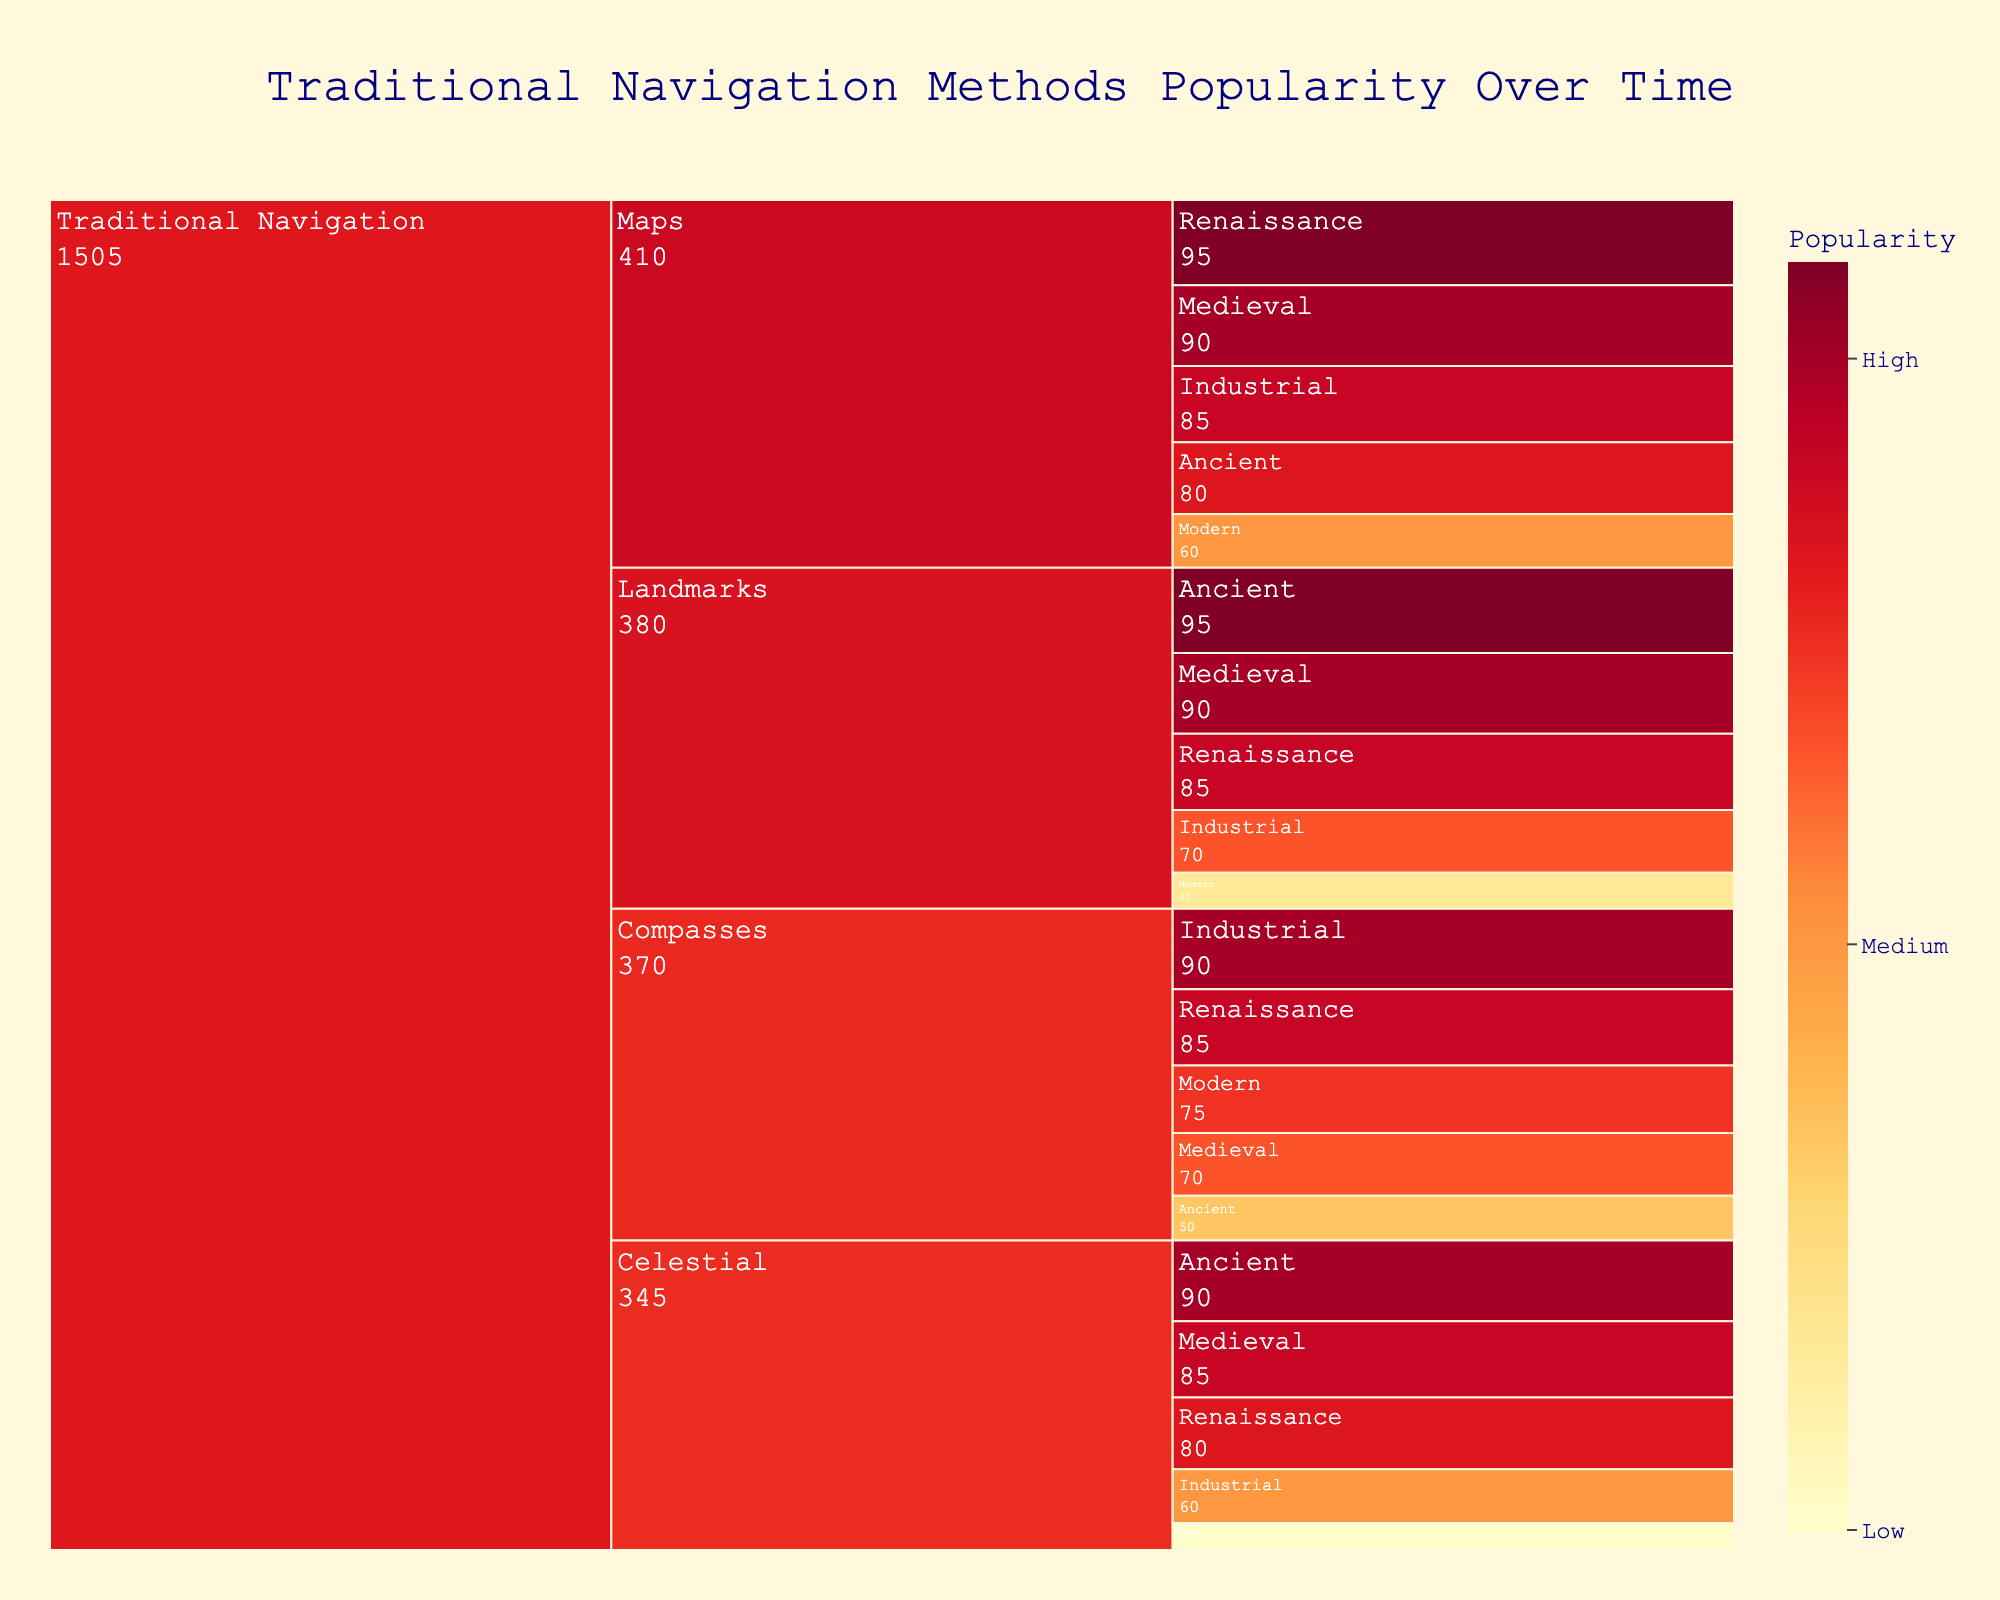What's the title of the figure? The title of the figure is written at the top of the chart.
Answer: Traditional Navigation Methods Popularity Over Time Which type of traditional navigation had the highest popularity in the Renaissance era? By looking at the Renaissance segment for each type and comparing their values, you'll see the highest number is under "Maps" with a value of 95.
Answer: Maps What is the least popular traditional navigation method in the modern era? Examine the modern era section for all types and identify the lowest value, which is "Celestial" with a value of 30.
Answer: Celestial How did the popularity of maps change from the ancient era to the modern era? The popularity for maps in the ancient era is 80 and in the modern era is 60. Subtract the modern value from the ancient value: 80 - 60 = 20, indicating a decrease of 20.
Answer: Decreased by 20 What is the average popularity of compasses over the five eras? Add the popularity values for compasses across all eras: 50 (Ancient) + 70 (Medieval) + 85 (Renaissance) + 90 (Industrial) + 75 (Modern) = 370, then divide by 5, which gives 370 / 5 = 74.
Answer: 74 Which traditional navigation method showed the most significant decline in popularity from the Industrial to the Modern era? For each method, find the difference in popularity between the Industrial and Modern eras: Maps (85 - 60 = 25), Compasses (90 - 75 = 15), Celestial (60 - 30 = 30), Landmarks (70 - 40 = 30). Both Celestial and Landmarks showed a decline of 30.
Answer: Celestial and Landmarks What is the total popularity of traditional navigation methods in the Medieval era? Sum the popularity values of all methods in the Medieval era: Maps (90) + Compasses (70) + Celestial (85) + Landmarks (90), which totals to 90 + 70 + 85 + 90 = 335.
Answer: 335 Which navigation method had a consistent decline in popularity across all eras? By looking at each era's values for all navigation methods, only "Celestial" shows a consistent decline: Ancient (90) > Medieval (85) > Renaissance (80) > Industrial (60) > Modern (30).
Answer: Celestial Which era had the highest cumulative popularity of all navigation methods combined? Calculate the sum of popularity for all types in each era and find the highest: Ancient (80+50+90+95 = 315), Medieval (90+70+85+90 = 335), Renaissance (95+85+80+85 = 345), Industrial (85+90+60+70 = 305), Modern (60+75+30+40 = 205). The highest sum is in the Renaissance era with 345.
Answer: Renaissance 